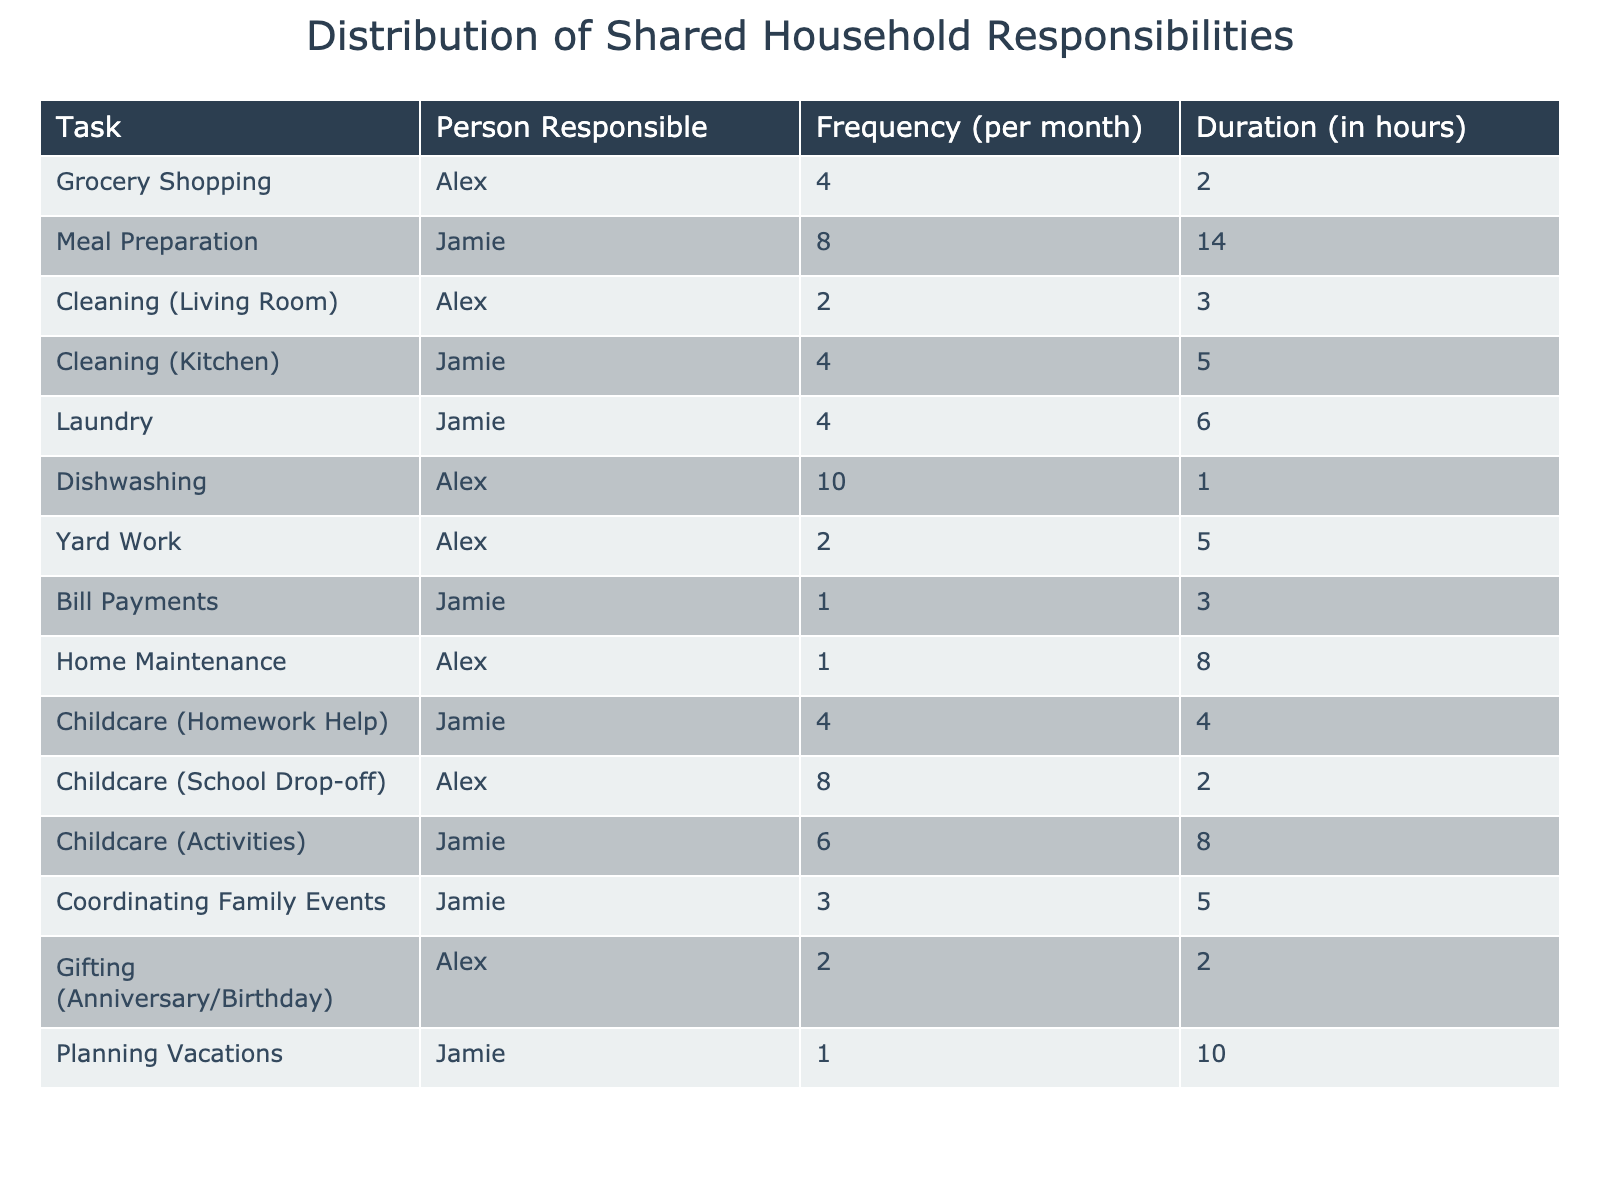What task does Jamie do the most frequently? By checking the 'Frequency (per month)' column, we see that Jamie is responsible for Meal Preparation with a frequency of 8 times per month, which is the highest value for Jamie in the table.
Answer: Meal Preparation How many hours does Alex spend on Dishwashing each month? Looking at the 'Duration (in hours)' column, Alex spends 1 hour per occasion on Dishwashing, and it occurs 10 times a month. Thus, the total hours spent is 10 * 1 = 10 hours.
Answer: 10 hours What is the combined frequency of Childcare tasks for both Alex and Jamie? We sum the frequencies of Childcare tasks from both Alex (2 for School Drop-off + 4 for Homework Help + 6 for Activities = 12) and Jamie (4 for Homework Help). Thus, the total is 12 + 4 = 16.
Answer: 16 Who spends more time on household tasks, Alex or Jamie? We need to calculate the total hours each person spends. For Alex: (4*2) + (2*3) + (10*1) + (2*5) + (1*8) + (2*2) = 8 + 6 + 10 + 10 + 8 + 4 = 56 hours. For Jamie: (8*14) + (4*5) + (4*6) + (1*3) + (6*8) + (3*5) + (1*10) = 112 + 20 + 24 + 3 + 48 + 15 + 10 = 232 hours. Since 232 > 56, Jamie spends more time.
Answer: Jamie What is the total frequency of tasks related to cleaning? We identify cleaning tasks: Cleaning (Living Room) and Cleaning (Kitchen). For Cleaning (Living Room), it's 2 times a month, and for Cleaning (Kitchen), it's 4 times a month. The total frequency is 2 + 4 = 6.
Answer: 6 Is there any task that both Alex and Jamie share responsibility for? Reviewing the table, there are no tasks listed where both Alex and Jamie are responsible. Each task is assigned exclusively to one or the other.
Answer: No On average, how many hours does Jamie spend on meal-related tasks per month? Jamie handles Meal Preparation (8 occurrences for 14 hours) and Laundry (4 occurrences for 6 hours). For Meal Preparation, total hours = 8 * 14 = 112 hours. For Laundry, total hours = 4 * 6 = 24 hours. So, the average is (112 + 24)/2 = 68 hours.
Answer: 68 hours What task has the lowest frequency in the table? Looking through the 'Frequency (per month)' column, the task with the lowest frequency is Bill Payments, which happens only once a month.
Answer: Bill Payments 